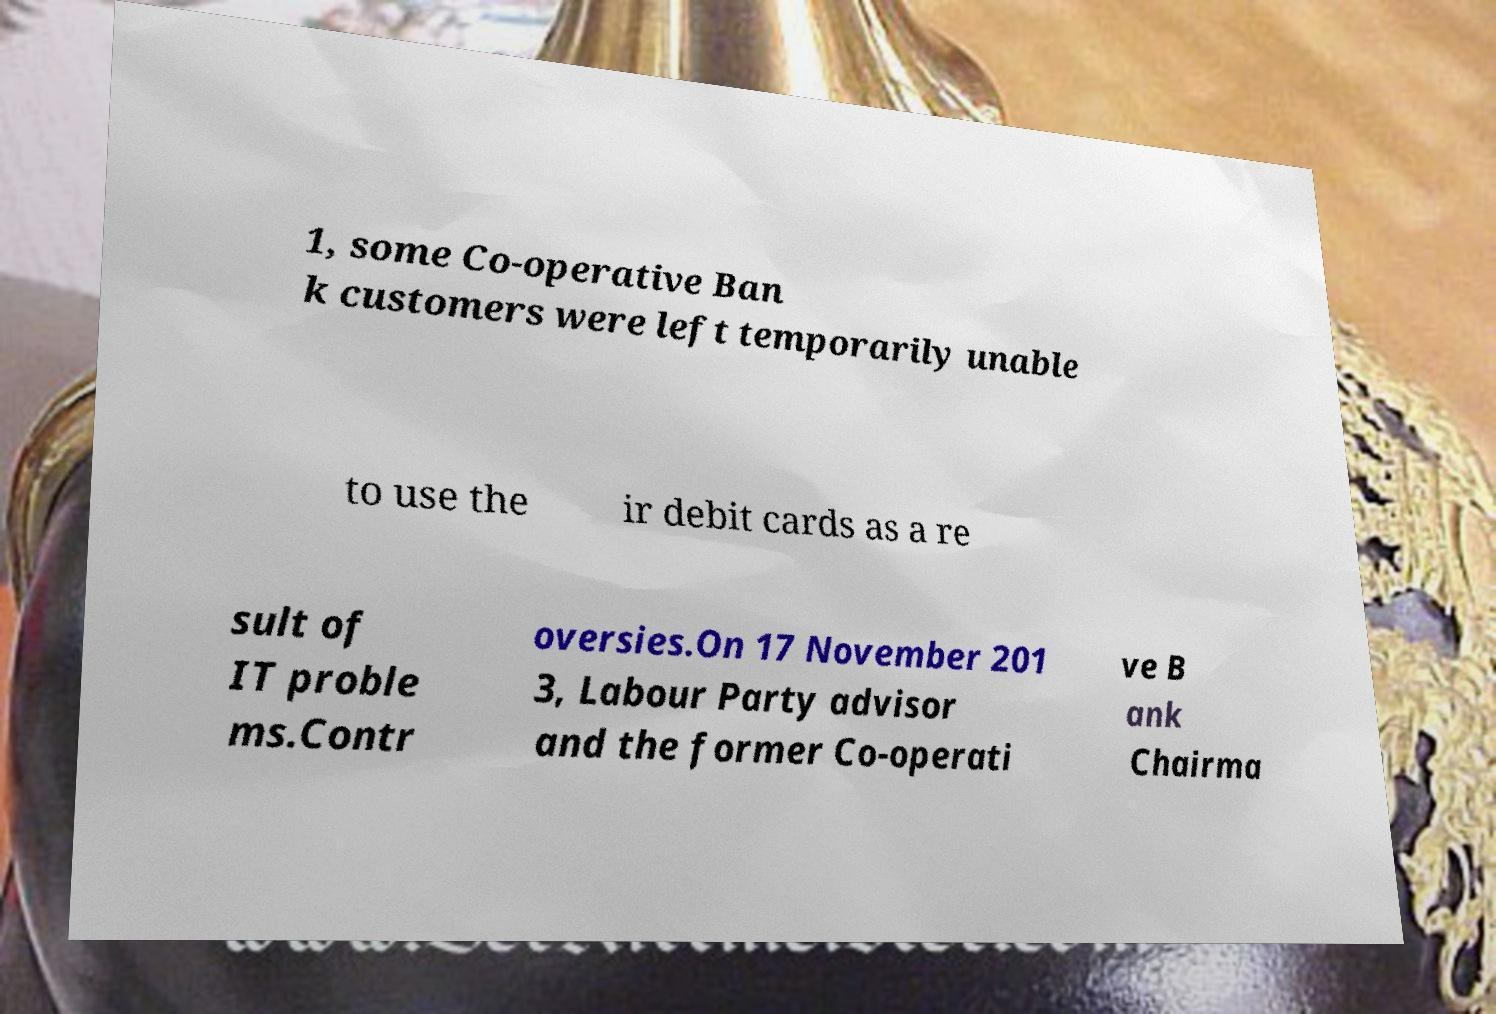Could you assist in decoding the text presented in this image and type it out clearly? 1, some Co-operative Ban k customers were left temporarily unable to use the ir debit cards as a re sult of IT proble ms.Contr oversies.On 17 November 201 3, Labour Party advisor and the former Co-operati ve B ank Chairma 